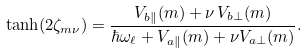Convert formula to latex. <formula><loc_0><loc_0><loc_500><loc_500>\tanh ( 2 \zeta _ { m \nu } ) = \frac { V _ { b \| } ( m ) + \nu \, V _ { b \perp } ( m ) } { \hbar { \omega } _ { \ell } + V _ { a \| } ( m ) + \nu V _ { a \perp } ( m ) } .</formula> 